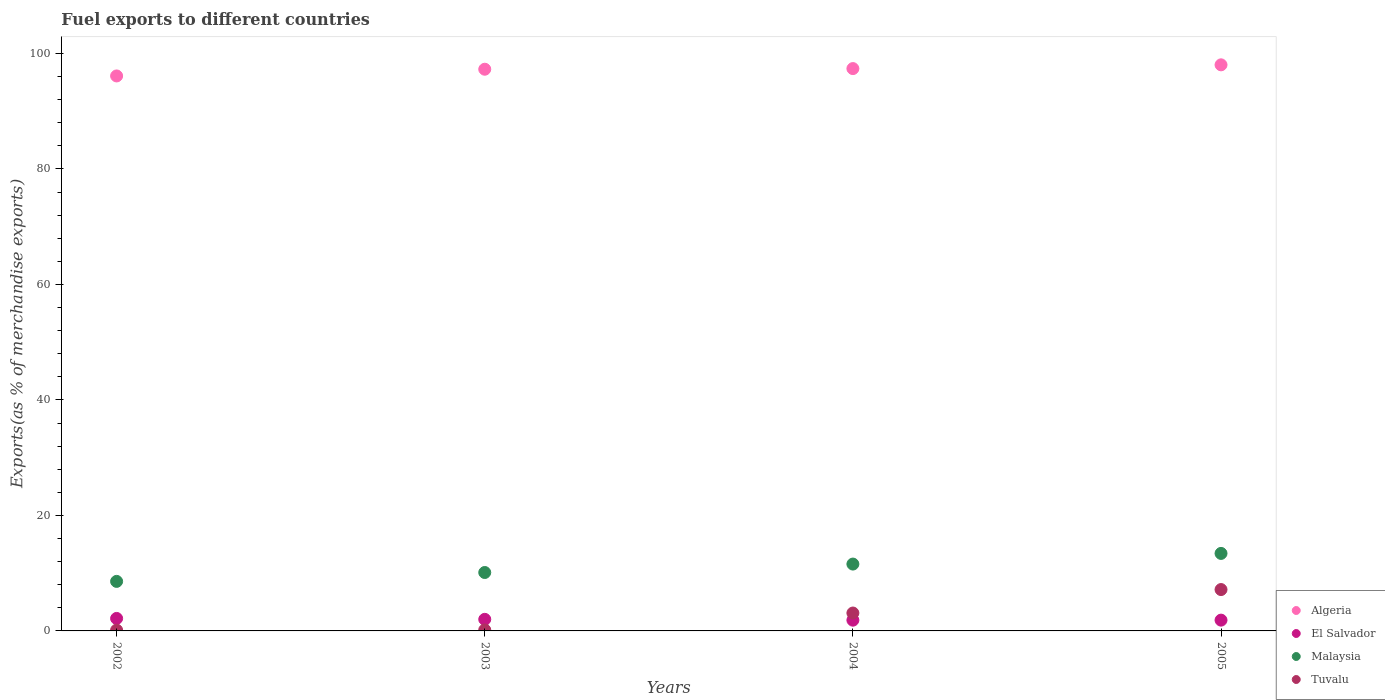How many different coloured dotlines are there?
Your response must be concise. 4. Is the number of dotlines equal to the number of legend labels?
Keep it short and to the point. Yes. What is the percentage of exports to different countries in El Salvador in 2003?
Keep it short and to the point. 2.01. Across all years, what is the maximum percentage of exports to different countries in Algeria?
Offer a very short reply. 98.03. Across all years, what is the minimum percentage of exports to different countries in Tuvalu?
Offer a very short reply. 0.14. What is the total percentage of exports to different countries in Algeria in the graph?
Give a very brief answer. 388.78. What is the difference between the percentage of exports to different countries in Malaysia in 2002 and that in 2005?
Your response must be concise. -4.84. What is the difference between the percentage of exports to different countries in Malaysia in 2002 and the percentage of exports to different countries in Tuvalu in 2003?
Your response must be concise. 8.41. What is the average percentage of exports to different countries in Tuvalu per year?
Give a very brief answer. 2.64. In the year 2005, what is the difference between the percentage of exports to different countries in Tuvalu and percentage of exports to different countries in El Salvador?
Your response must be concise. 5.3. In how many years, is the percentage of exports to different countries in Malaysia greater than 40 %?
Give a very brief answer. 0. What is the ratio of the percentage of exports to different countries in Tuvalu in 2002 to that in 2005?
Give a very brief answer. 0.02. Is the difference between the percentage of exports to different countries in Tuvalu in 2002 and 2004 greater than the difference between the percentage of exports to different countries in El Salvador in 2002 and 2004?
Keep it short and to the point. No. What is the difference between the highest and the second highest percentage of exports to different countries in Algeria?
Your response must be concise. 0.65. What is the difference between the highest and the lowest percentage of exports to different countries in El Salvador?
Your answer should be compact. 0.3. In how many years, is the percentage of exports to different countries in Tuvalu greater than the average percentage of exports to different countries in Tuvalu taken over all years?
Your answer should be very brief. 2. Is the sum of the percentage of exports to different countries in Tuvalu in 2002 and 2004 greater than the maximum percentage of exports to different countries in El Salvador across all years?
Your answer should be very brief. Yes. Does the percentage of exports to different countries in Tuvalu monotonically increase over the years?
Provide a short and direct response. Yes. Is the percentage of exports to different countries in El Salvador strictly greater than the percentage of exports to different countries in Tuvalu over the years?
Keep it short and to the point. No. Is the percentage of exports to different countries in El Salvador strictly less than the percentage of exports to different countries in Tuvalu over the years?
Provide a short and direct response. No. Are the values on the major ticks of Y-axis written in scientific E-notation?
Give a very brief answer. No. Does the graph contain any zero values?
Your answer should be compact. No. Where does the legend appear in the graph?
Keep it short and to the point. Bottom right. What is the title of the graph?
Offer a terse response. Fuel exports to different countries. What is the label or title of the X-axis?
Provide a succinct answer. Years. What is the label or title of the Y-axis?
Give a very brief answer. Exports(as % of merchandise exports). What is the Exports(as % of merchandise exports) in Algeria in 2002?
Give a very brief answer. 96.11. What is the Exports(as % of merchandise exports) of El Salvador in 2002?
Your response must be concise. 2.16. What is the Exports(as % of merchandise exports) of Malaysia in 2002?
Provide a succinct answer. 8.58. What is the Exports(as % of merchandise exports) of Tuvalu in 2002?
Ensure brevity in your answer.  0.14. What is the Exports(as % of merchandise exports) of Algeria in 2003?
Your response must be concise. 97.27. What is the Exports(as % of merchandise exports) in El Salvador in 2003?
Offer a terse response. 2.01. What is the Exports(as % of merchandise exports) in Malaysia in 2003?
Offer a very short reply. 10.12. What is the Exports(as % of merchandise exports) in Tuvalu in 2003?
Offer a very short reply. 0.17. What is the Exports(as % of merchandise exports) in Algeria in 2004?
Your response must be concise. 97.38. What is the Exports(as % of merchandise exports) of El Salvador in 2004?
Provide a succinct answer. 1.86. What is the Exports(as % of merchandise exports) in Malaysia in 2004?
Your answer should be very brief. 11.58. What is the Exports(as % of merchandise exports) of Tuvalu in 2004?
Keep it short and to the point. 3.1. What is the Exports(as % of merchandise exports) of Algeria in 2005?
Your answer should be compact. 98.03. What is the Exports(as % of merchandise exports) in El Salvador in 2005?
Your answer should be compact. 1.87. What is the Exports(as % of merchandise exports) of Malaysia in 2005?
Provide a short and direct response. 13.42. What is the Exports(as % of merchandise exports) of Tuvalu in 2005?
Keep it short and to the point. 7.16. Across all years, what is the maximum Exports(as % of merchandise exports) of Algeria?
Provide a short and direct response. 98.03. Across all years, what is the maximum Exports(as % of merchandise exports) in El Salvador?
Ensure brevity in your answer.  2.16. Across all years, what is the maximum Exports(as % of merchandise exports) of Malaysia?
Ensure brevity in your answer.  13.42. Across all years, what is the maximum Exports(as % of merchandise exports) in Tuvalu?
Offer a terse response. 7.16. Across all years, what is the minimum Exports(as % of merchandise exports) in Algeria?
Your response must be concise. 96.11. Across all years, what is the minimum Exports(as % of merchandise exports) of El Salvador?
Keep it short and to the point. 1.86. Across all years, what is the minimum Exports(as % of merchandise exports) of Malaysia?
Ensure brevity in your answer.  8.58. Across all years, what is the minimum Exports(as % of merchandise exports) in Tuvalu?
Provide a succinct answer. 0.14. What is the total Exports(as % of merchandise exports) in Algeria in the graph?
Provide a short and direct response. 388.78. What is the total Exports(as % of merchandise exports) in El Salvador in the graph?
Make the answer very short. 7.9. What is the total Exports(as % of merchandise exports) in Malaysia in the graph?
Keep it short and to the point. 43.69. What is the total Exports(as % of merchandise exports) of Tuvalu in the graph?
Provide a succinct answer. 10.57. What is the difference between the Exports(as % of merchandise exports) of Algeria in 2002 and that in 2003?
Your answer should be very brief. -1.16. What is the difference between the Exports(as % of merchandise exports) in El Salvador in 2002 and that in 2003?
Provide a succinct answer. 0.16. What is the difference between the Exports(as % of merchandise exports) in Malaysia in 2002 and that in 2003?
Keep it short and to the point. -1.54. What is the difference between the Exports(as % of merchandise exports) of Tuvalu in 2002 and that in 2003?
Your response must be concise. -0.03. What is the difference between the Exports(as % of merchandise exports) of Algeria in 2002 and that in 2004?
Keep it short and to the point. -1.27. What is the difference between the Exports(as % of merchandise exports) in El Salvador in 2002 and that in 2004?
Provide a short and direct response. 0.3. What is the difference between the Exports(as % of merchandise exports) of Malaysia in 2002 and that in 2004?
Make the answer very short. -3. What is the difference between the Exports(as % of merchandise exports) of Tuvalu in 2002 and that in 2004?
Keep it short and to the point. -2.96. What is the difference between the Exports(as % of merchandise exports) of Algeria in 2002 and that in 2005?
Ensure brevity in your answer.  -1.92. What is the difference between the Exports(as % of merchandise exports) in El Salvador in 2002 and that in 2005?
Give a very brief answer. 0.29. What is the difference between the Exports(as % of merchandise exports) of Malaysia in 2002 and that in 2005?
Keep it short and to the point. -4.84. What is the difference between the Exports(as % of merchandise exports) in Tuvalu in 2002 and that in 2005?
Offer a terse response. -7.02. What is the difference between the Exports(as % of merchandise exports) in Algeria in 2003 and that in 2004?
Your answer should be compact. -0.11. What is the difference between the Exports(as % of merchandise exports) of El Salvador in 2003 and that in 2004?
Give a very brief answer. 0.14. What is the difference between the Exports(as % of merchandise exports) of Malaysia in 2003 and that in 2004?
Your response must be concise. -1.46. What is the difference between the Exports(as % of merchandise exports) in Tuvalu in 2003 and that in 2004?
Offer a very short reply. -2.93. What is the difference between the Exports(as % of merchandise exports) in Algeria in 2003 and that in 2005?
Offer a very short reply. -0.76. What is the difference between the Exports(as % of merchandise exports) in El Salvador in 2003 and that in 2005?
Your response must be concise. 0.14. What is the difference between the Exports(as % of merchandise exports) in Malaysia in 2003 and that in 2005?
Provide a short and direct response. -3.31. What is the difference between the Exports(as % of merchandise exports) of Tuvalu in 2003 and that in 2005?
Give a very brief answer. -6.99. What is the difference between the Exports(as % of merchandise exports) in Algeria in 2004 and that in 2005?
Ensure brevity in your answer.  -0.65. What is the difference between the Exports(as % of merchandise exports) of El Salvador in 2004 and that in 2005?
Provide a short and direct response. -0.01. What is the difference between the Exports(as % of merchandise exports) in Malaysia in 2004 and that in 2005?
Your answer should be very brief. -1.84. What is the difference between the Exports(as % of merchandise exports) of Tuvalu in 2004 and that in 2005?
Ensure brevity in your answer.  -4.06. What is the difference between the Exports(as % of merchandise exports) in Algeria in 2002 and the Exports(as % of merchandise exports) in El Salvador in 2003?
Provide a short and direct response. 94.1. What is the difference between the Exports(as % of merchandise exports) in Algeria in 2002 and the Exports(as % of merchandise exports) in Malaysia in 2003?
Make the answer very short. 85.99. What is the difference between the Exports(as % of merchandise exports) of Algeria in 2002 and the Exports(as % of merchandise exports) of Tuvalu in 2003?
Your answer should be compact. 95.93. What is the difference between the Exports(as % of merchandise exports) of El Salvador in 2002 and the Exports(as % of merchandise exports) of Malaysia in 2003?
Offer a very short reply. -7.95. What is the difference between the Exports(as % of merchandise exports) in El Salvador in 2002 and the Exports(as % of merchandise exports) in Tuvalu in 2003?
Offer a terse response. 1.99. What is the difference between the Exports(as % of merchandise exports) in Malaysia in 2002 and the Exports(as % of merchandise exports) in Tuvalu in 2003?
Offer a terse response. 8.41. What is the difference between the Exports(as % of merchandise exports) of Algeria in 2002 and the Exports(as % of merchandise exports) of El Salvador in 2004?
Provide a short and direct response. 94.24. What is the difference between the Exports(as % of merchandise exports) of Algeria in 2002 and the Exports(as % of merchandise exports) of Malaysia in 2004?
Make the answer very short. 84.53. What is the difference between the Exports(as % of merchandise exports) in Algeria in 2002 and the Exports(as % of merchandise exports) in Tuvalu in 2004?
Your answer should be very brief. 93.01. What is the difference between the Exports(as % of merchandise exports) in El Salvador in 2002 and the Exports(as % of merchandise exports) in Malaysia in 2004?
Provide a succinct answer. -9.41. What is the difference between the Exports(as % of merchandise exports) in El Salvador in 2002 and the Exports(as % of merchandise exports) in Tuvalu in 2004?
Your response must be concise. -0.94. What is the difference between the Exports(as % of merchandise exports) of Malaysia in 2002 and the Exports(as % of merchandise exports) of Tuvalu in 2004?
Your answer should be compact. 5.48. What is the difference between the Exports(as % of merchandise exports) in Algeria in 2002 and the Exports(as % of merchandise exports) in El Salvador in 2005?
Ensure brevity in your answer.  94.24. What is the difference between the Exports(as % of merchandise exports) in Algeria in 2002 and the Exports(as % of merchandise exports) in Malaysia in 2005?
Ensure brevity in your answer.  82.68. What is the difference between the Exports(as % of merchandise exports) of Algeria in 2002 and the Exports(as % of merchandise exports) of Tuvalu in 2005?
Your answer should be compact. 88.94. What is the difference between the Exports(as % of merchandise exports) in El Salvador in 2002 and the Exports(as % of merchandise exports) in Malaysia in 2005?
Offer a very short reply. -11.26. What is the difference between the Exports(as % of merchandise exports) of El Salvador in 2002 and the Exports(as % of merchandise exports) of Tuvalu in 2005?
Your answer should be very brief. -5. What is the difference between the Exports(as % of merchandise exports) of Malaysia in 2002 and the Exports(as % of merchandise exports) of Tuvalu in 2005?
Provide a short and direct response. 1.41. What is the difference between the Exports(as % of merchandise exports) of Algeria in 2003 and the Exports(as % of merchandise exports) of El Salvador in 2004?
Make the answer very short. 95.41. What is the difference between the Exports(as % of merchandise exports) of Algeria in 2003 and the Exports(as % of merchandise exports) of Malaysia in 2004?
Offer a terse response. 85.69. What is the difference between the Exports(as % of merchandise exports) of Algeria in 2003 and the Exports(as % of merchandise exports) of Tuvalu in 2004?
Provide a succinct answer. 94.17. What is the difference between the Exports(as % of merchandise exports) of El Salvador in 2003 and the Exports(as % of merchandise exports) of Malaysia in 2004?
Your response must be concise. -9.57. What is the difference between the Exports(as % of merchandise exports) of El Salvador in 2003 and the Exports(as % of merchandise exports) of Tuvalu in 2004?
Offer a terse response. -1.09. What is the difference between the Exports(as % of merchandise exports) of Malaysia in 2003 and the Exports(as % of merchandise exports) of Tuvalu in 2004?
Provide a succinct answer. 7.02. What is the difference between the Exports(as % of merchandise exports) of Algeria in 2003 and the Exports(as % of merchandise exports) of El Salvador in 2005?
Your response must be concise. 95.4. What is the difference between the Exports(as % of merchandise exports) in Algeria in 2003 and the Exports(as % of merchandise exports) in Malaysia in 2005?
Offer a terse response. 83.85. What is the difference between the Exports(as % of merchandise exports) of Algeria in 2003 and the Exports(as % of merchandise exports) of Tuvalu in 2005?
Keep it short and to the point. 90.1. What is the difference between the Exports(as % of merchandise exports) in El Salvador in 2003 and the Exports(as % of merchandise exports) in Malaysia in 2005?
Your answer should be compact. -11.42. What is the difference between the Exports(as % of merchandise exports) in El Salvador in 2003 and the Exports(as % of merchandise exports) in Tuvalu in 2005?
Provide a short and direct response. -5.16. What is the difference between the Exports(as % of merchandise exports) of Malaysia in 2003 and the Exports(as % of merchandise exports) of Tuvalu in 2005?
Provide a short and direct response. 2.95. What is the difference between the Exports(as % of merchandise exports) of Algeria in 2004 and the Exports(as % of merchandise exports) of El Salvador in 2005?
Provide a succinct answer. 95.51. What is the difference between the Exports(as % of merchandise exports) of Algeria in 2004 and the Exports(as % of merchandise exports) of Malaysia in 2005?
Give a very brief answer. 83.96. What is the difference between the Exports(as % of merchandise exports) in Algeria in 2004 and the Exports(as % of merchandise exports) in Tuvalu in 2005?
Keep it short and to the point. 90.22. What is the difference between the Exports(as % of merchandise exports) of El Salvador in 2004 and the Exports(as % of merchandise exports) of Malaysia in 2005?
Provide a short and direct response. -11.56. What is the difference between the Exports(as % of merchandise exports) of El Salvador in 2004 and the Exports(as % of merchandise exports) of Tuvalu in 2005?
Your answer should be compact. -5.3. What is the difference between the Exports(as % of merchandise exports) in Malaysia in 2004 and the Exports(as % of merchandise exports) in Tuvalu in 2005?
Your answer should be compact. 4.41. What is the average Exports(as % of merchandise exports) in Algeria per year?
Make the answer very short. 97.19. What is the average Exports(as % of merchandise exports) in El Salvador per year?
Your answer should be very brief. 1.97. What is the average Exports(as % of merchandise exports) of Malaysia per year?
Your answer should be very brief. 10.92. What is the average Exports(as % of merchandise exports) of Tuvalu per year?
Offer a terse response. 2.64. In the year 2002, what is the difference between the Exports(as % of merchandise exports) in Algeria and Exports(as % of merchandise exports) in El Salvador?
Offer a very short reply. 93.94. In the year 2002, what is the difference between the Exports(as % of merchandise exports) in Algeria and Exports(as % of merchandise exports) in Malaysia?
Offer a very short reply. 87.53. In the year 2002, what is the difference between the Exports(as % of merchandise exports) of Algeria and Exports(as % of merchandise exports) of Tuvalu?
Keep it short and to the point. 95.97. In the year 2002, what is the difference between the Exports(as % of merchandise exports) of El Salvador and Exports(as % of merchandise exports) of Malaysia?
Provide a short and direct response. -6.42. In the year 2002, what is the difference between the Exports(as % of merchandise exports) of El Salvador and Exports(as % of merchandise exports) of Tuvalu?
Your response must be concise. 2.02. In the year 2002, what is the difference between the Exports(as % of merchandise exports) of Malaysia and Exports(as % of merchandise exports) of Tuvalu?
Offer a very short reply. 8.44. In the year 2003, what is the difference between the Exports(as % of merchandise exports) in Algeria and Exports(as % of merchandise exports) in El Salvador?
Make the answer very short. 95.26. In the year 2003, what is the difference between the Exports(as % of merchandise exports) in Algeria and Exports(as % of merchandise exports) in Malaysia?
Make the answer very short. 87.15. In the year 2003, what is the difference between the Exports(as % of merchandise exports) of Algeria and Exports(as % of merchandise exports) of Tuvalu?
Ensure brevity in your answer.  97.09. In the year 2003, what is the difference between the Exports(as % of merchandise exports) in El Salvador and Exports(as % of merchandise exports) in Malaysia?
Give a very brief answer. -8.11. In the year 2003, what is the difference between the Exports(as % of merchandise exports) in El Salvador and Exports(as % of merchandise exports) in Tuvalu?
Your answer should be very brief. 1.83. In the year 2003, what is the difference between the Exports(as % of merchandise exports) of Malaysia and Exports(as % of merchandise exports) of Tuvalu?
Keep it short and to the point. 9.94. In the year 2004, what is the difference between the Exports(as % of merchandise exports) in Algeria and Exports(as % of merchandise exports) in El Salvador?
Provide a succinct answer. 95.52. In the year 2004, what is the difference between the Exports(as % of merchandise exports) in Algeria and Exports(as % of merchandise exports) in Malaysia?
Ensure brevity in your answer.  85.8. In the year 2004, what is the difference between the Exports(as % of merchandise exports) in Algeria and Exports(as % of merchandise exports) in Tuvalu?
Your response must be concise. 94.28. In the year 2004, what is the difference between the Exports(as % of merchandise exports) in El Salvador and Exports(as % of merchandise exports) in Malaysia?
Make the answer very short. -9.72. In the year 2004, what is the difference between the Exports(as % of merchandise exports) of El Salvador and Exports(as % of merchandise exports) of Tuvalu?
Ensure brevity in your answer.  -1.24. In the year 2004, what is the difference between the Exports(as % of merchandise exports) in Malaysia and Exports(as % of merchandise exports) in Tuvalu?
Give a very brief answer. 8.48. In the year 2005, what is the difference between the Exports(as % of merchandise exports) in Algeria and Exports(as % of merchandise exports) in El Salvador?
Your answer should be very brief. 96.16. In the year 2005, what is the difference between the Exports(as % of merchandise exports) in Algeria and Exports(as % of merchandise exports) in Malaysia?
Make the answer very short. 84.61. In the year 2005, what is the difference between the Exports(as % of merchandise exports) of Algeria and Exports(as % of merchandise exports) of Tuvalu?
Offer a very short reply. 90.86. In the year 2005, what is the difference between the Exports(as % of merchandise exports) of El Salvador and Exports(as % of merchandise exports) of Malaysia?
Your response must be concise. -11.55. In the year 2005, what is the difference between the Exports(as % of merchandise exports) in El Salvador and Exports(as % of merchandise exports) in Tuvalu?
Keep it short and to the point. -5.3. In the year 2005, what is the difference between the Exports(as % of merchandise exports) of Malaysia and Exports(as % of merchandise exports) of Tuvalu?
Ensure brevity in your answer.  6.26. What is the ratio of the Exports(as % of merchandise exports) of El Salvador in 2002 to that in 2003?
Your answer should be very brief. 1.08. What is the ratio of the Exports(as % of merchandise exports) in Malaysia in 2002 to that in 2003?
Keep it short and to the point. 0.85. What is the ratio of the Exports(as % of merchandise exports) of Tuvalu in 2002 to that in 2003?
Provide a succinct answer. 0.8. What is the ratio of the Exports(as % of merchandise exports) in Algeria in 2002 to that in 2004?
Offer a terse response. 0.99. What is the ratio of the Exports(as % of merchandise exports) of El Salvador in 2002 to that in 2004?
Your response must be concise. 1.16. What is the ratio of the Exports(as % of merchandise exports) of Malaysia in 2002 to that in 2004?
Make the answer very short. 0.74. What is the ratio of the Exports(as % of merchandise exports) of Tuvalu in 2002 to that in 2004?
Offer a very short reply. 0.04. What is the ratio of the Exports(as % of merchandise exports) in Algeria in 2002 to that in 2005?
Ensure brevity in your answer.  0.98. What is the ratio of the Exports(as % of merchandise exports) of El Salvador in 2002 to that in 2005?
Your response must be concise. 1.16. What is the ratio of the Exports(as % of merchandise exports) of Malaysia in 2002 to that in 2005?
Provide a succinct answer. 0.64. What is the ratio of the Exports(as % of merchandise exports) of Tuvalu in 2002 to that in 2005?
Offer a terse response. 0.02. What is the ratio of the Exports(as % of merchandise exports) of Algeria in 2003 to that in 2004?
Offer a very short reply. 1. What is the ratio of the Exports(as % of merchandise exports) of El Salvador in 2003 to that in 2004?
Offer a very short reply. 1.08. What is the ratio of the Exports(as % of merchandise exports) of Malaysia in 2003 to that in 2004?
Your answer should be very brief. 0.87. What is the ratio of the Exports(as % of merchandise exports) in Tuvalu in 2003 to that in 2004?
Offer a very short reply. 0.06. What is the ratio of the Exports(as % of merchandise exports) of El Salvador in 2003 to that in 2005?
Provide a succinct answer. 1.07. What is the ratio of the Exports(as % of merchandise exports) in Malaysia in 2003 to that in 2005?
Your response must be concise. 0.75. What is the ratio of the Exports(as % of merchandise exports) of Tuvalu in 2003 to that in 2005?
Provide a succinct answer. 0.02. What is the ratio of the Exports(as % of merchandise exports) in Algeria in 2004 to that in 2005?
Keep it short and to the point. 0.99. What is the ratio of the Exports(as % of merchandise exports) in El Salvador in 2004 to that in 2005?
Provide a short and direct response. 1. What is the ratio of the Exports(as % of merchandise exports) in Malaysia in 2004 to that in 2005?
Give a very brief answer. 0.86. What is the ratio of the Exports(as % of merchandise exports) of Tuvalu in 2004 to that in 2005?
Make the answer very short. 0.43. What is the difference between the highest and the second highest Exports(as % of merchandise exports) of Algeria?
Offer a terse response. 0.65. What is the difference between the highest and the second highest Exports(as % of merchandise exports) of El Salvador?
Your response must be concise. 0.16. What is the difference between the highest and the second highest Exports(as % of merchandise exports) of Malaysia?
Provide a short and direct response. 1.84. What is the difference between the highest and the second highest Exports(as % of merchandise exports) in Tuvalu?
Your answer should be compact. 4.06. What is the difference between the highest and the lowest Exports(as % of merchandise exports) in Algeria?
Make the answer very short. 1.92. What is the difference between the highest and the lowest Exports(as % of merchandise exports) in El Salvador?
Your answer should be compact. 0.3. What is the difference between the highest and the lowest Exports(as % of merchandise exports) in Malaysia?
Offer a terse response. 4.84. What is the difference between the highest and the lowest Exports(as % of merchandise exports) in Tuvalu?
Make the answer very short. 7.02. 